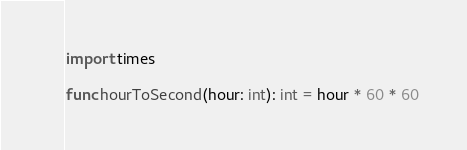Convert code to text. <code><loc_0><loc_0><loc_500><loc_500><_Nim_>import times

func hourToSecond(hour: int): int = hour * 60 * 60
</code> 